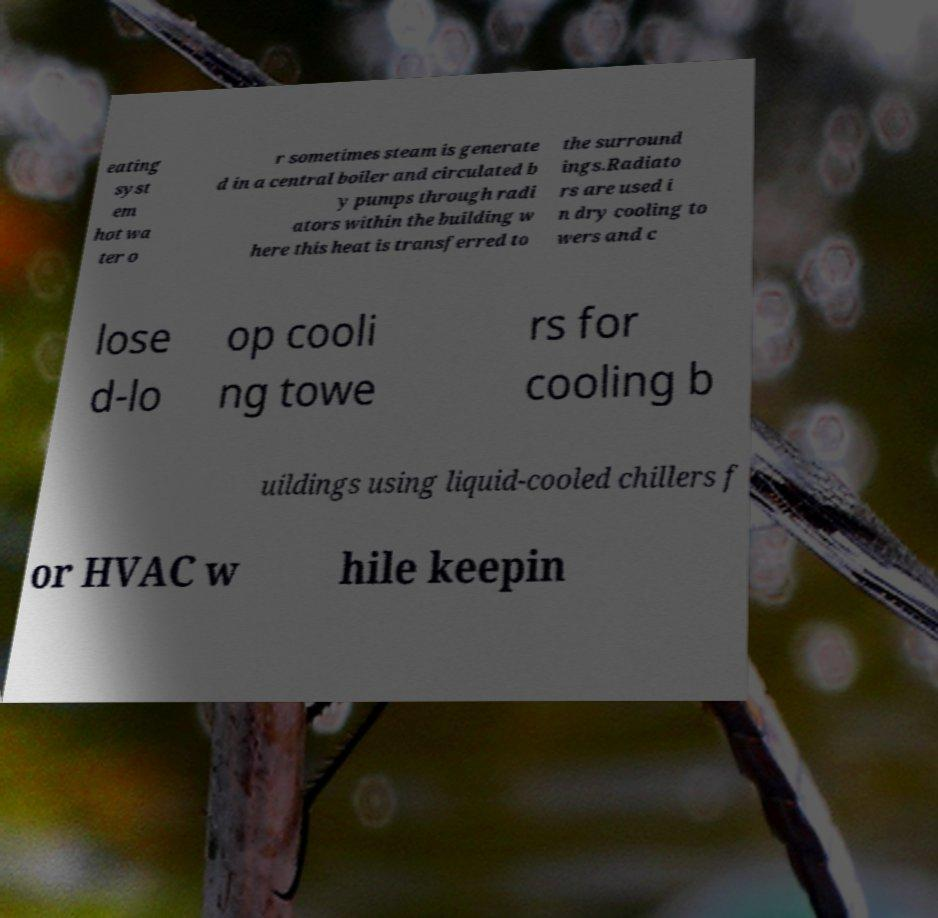Can you read and provide the text displayed in the image?This photo seems to have some interesting text. Can you extract and type it out for me? eating syst em hot wa ter o r sometimes steam is generate d in a central boiler and circulated b y pumps through radi ators within the building w here this heat is transferred to the surround ings.Radiato rs are used i n dry cooling to wers and c lose d-lo op cooli ng towe rs for cooling b uildings using liquid-cooled chillers f or HVAC w hile keepin 